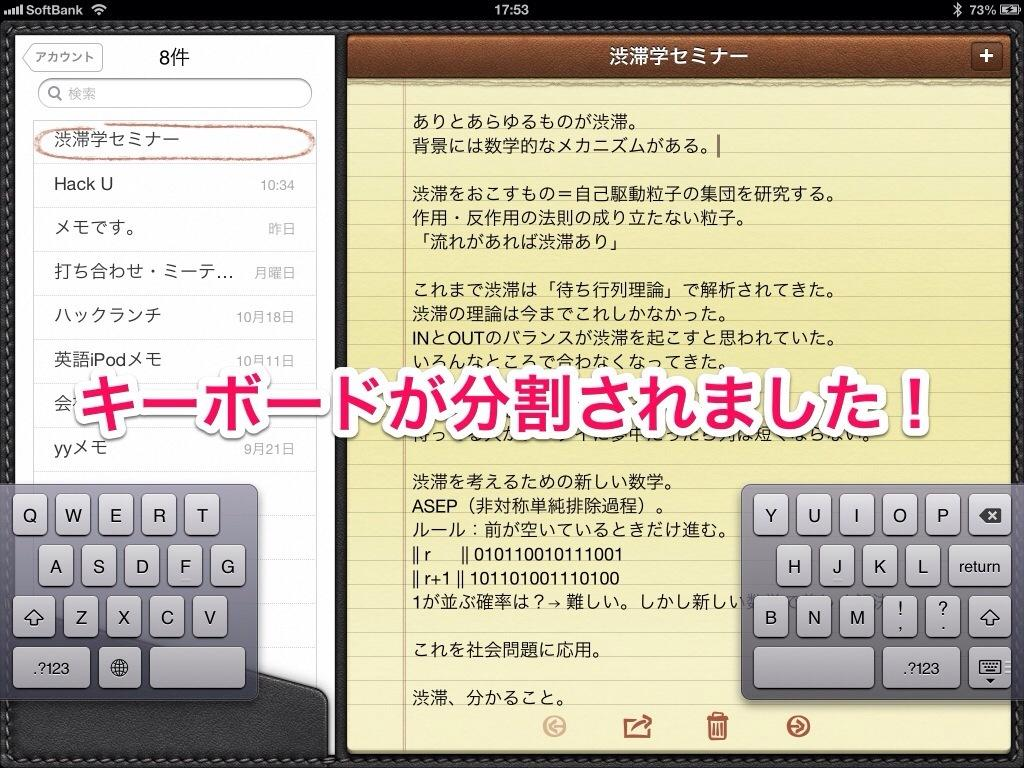Provide a one-sentence caption for the provided image. A virtual keyboard on notepad app for Softbank screenshot at 17:53. 